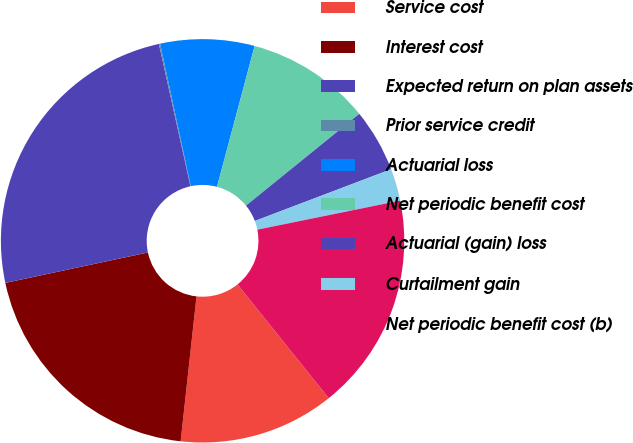Convert chart. <chart><loc_0><loc_0><loc_500><loc_500><pie_chart><fcel>Service cost<fcel>Interest cost<fcel>Expected return on plan assets<fcel>Prior service credit<fcel>Actuarial loss<fcel>Net periodic benefit cost<fcel>Actuarial (gain) loss<fcel>Curtailment gain<fcel>Net periodic benefit cost (b)<nl><fcel>12.49%<fcel>19.92%<fcel>24.87%<fcel>0.1%<fcel>7.53%<fcel>10.01%<fcel>5.06%<fcel>2.58%<fcel>17.44%<nl></chart> 